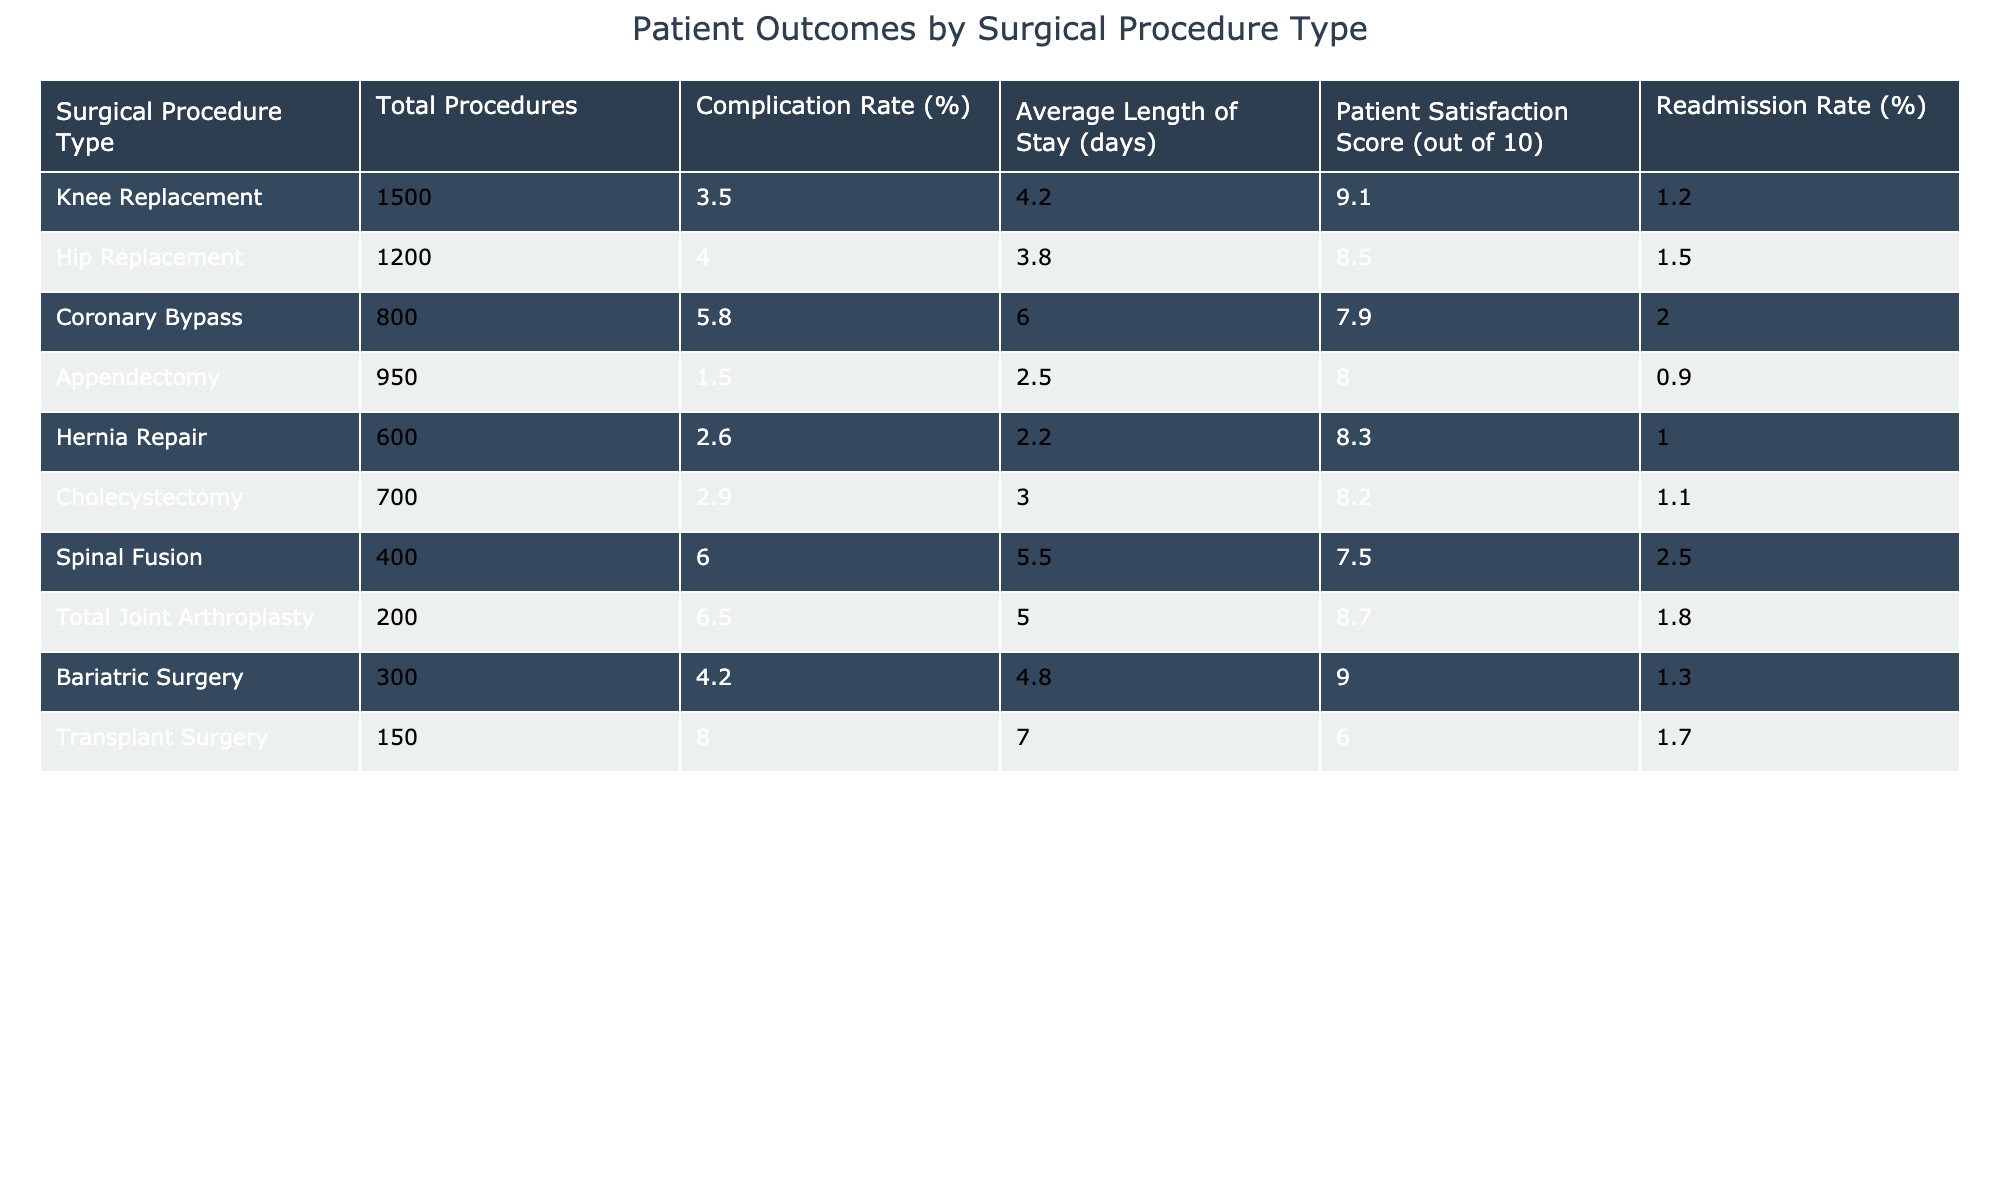What is the complication rate for Knee Replacement? The complication rate is listed directly next to the Knee Replacement procedure in the table. The value provided is 3.5%.
Answer: 3.5% What is the average length of stay for Coronary Bypass patients? The average length of stay for Coronary Bypass patients is found in the corresponding row for this procedure in the table, which states it is 6.0 days.
Answer: 6.0 days Which surgical procedure has the highest readmission rate? By comparing the readmission rates across all surgical procedures, it is visible that Transplant Surgery has the highest rate at 8.0%.
Answer: Transplant Surgery What is the average patient satisfaction score for all procedures combined? To find the average, the satisfaction scores are summed (9.1 + 8.5 + 7.9 + 8.0 + 8.3 + 8.2 + 7.5 + 8.7 + 9.0 + 6.0 = 81.2) and then divided by the number of procedures (10). So, 81.2 / 10 = 8.12.
Answer: 8.12 Is the complication rate for Hip Replacement higher than that for Appendectomy? Look at the complication rates for both procedures: Hip Replacement has a rate of 4.0% and Appendectomy has a rate of 1.5%. Since 4.0% is greater than 1.5%, the answer is yes.
Answer: Yes What is the difference in complication rates between Spinal Fusion and Hernia Repair? The complication rate for Spinal Fusion is 6.0% and for Hernia Repair is 2.6%. The difference is calculated as 6.0% - 2.6% = 3.4%.
Answer: 3.4% Which type of surgery has the lowest patient satisfaction score? By reviewing the patient satisfaction scores in the table, Total Joint Arthroplasty has the lowest score at 8.7, compared to other scores.
Answer: Total Joint Arthroplasty How many total procedures were performed across all types of surgeries listed? The total number of procedures can be calculated by summing the Total Procedures column (1500 + 1200 + 800 + 950 + 600 + 700 + 400 + 200 + 300 + 150 = 5850).
Answer: 5850 If we compare the average length of stay for procedures with a complication rate greater than 5%, what is the average length of stay? First, identify the procedures with a complication rate greater than 5% (Coronary Bypass, Spinal Fusion, Total Joint Arthroplasty, and Transplant Surgery) with lengths of stay of 6.0, 5.5, 5.0, and 7.0 days respectively. Summing these gives (6.0 + 5.5 + 5.0 + 7.0 = 23.5) and dividing by the number of such procedures (4) gives 23.5 / 4 = 5.875 days.
Answer: 5.875 days What percentage of procedures resulted in complications for surgeries with a complication rate lower than 3%? To calculate, only consider Appendectomy (1.5%) and Hernia Repair (2.6%) for a total of 950 + 600 = 1550 total procedures. Complications occurred in 1.5% of Add to 2.6% of Hernia, thus 1.5% * 950 + 2.6% * 600 = 14.25 + 15.6 = 29.85 complications. The percentage of procedures with complications is (29.85 / 1550) * 100 = 1.93%.
Answer: 1.93% 